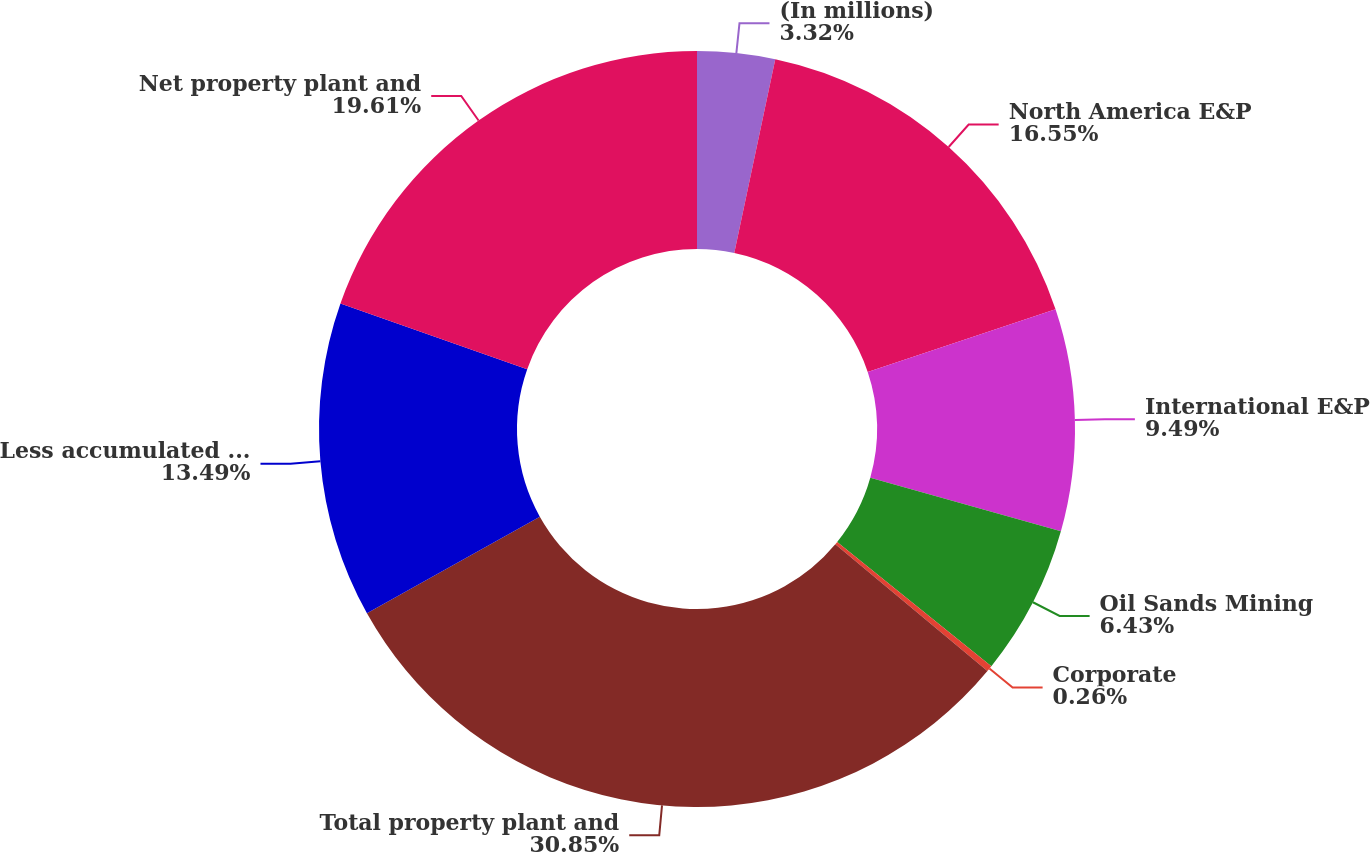Convert chart to OTSL. <chart><loc_0><loc_0><loc_500><loc_500><pie_chart><fcel>(In millions)<fcel>North America E&P<fcel>International E&P<fcel>Oil Sands Mining<fcel>Corporate<fcel>Total property plant and<fcel>Less accumulated depreciation<fcel>Net property plant and<nl><fcel>3.32%<fcel>16.55%<fcel>9.49%<fcel>6.43%<fcel>0.26%<fcel>30.84%<fcel>13.49%<fcel>19.61%<nl></chart> 